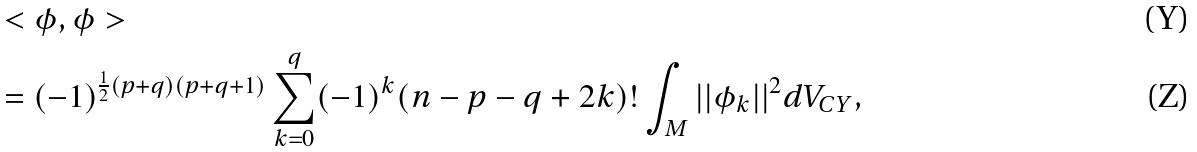Convert formula to latex. <formula><loc_0><loc_0><loc_500><loc_500>& < \phi , \phi > \\ & = ( - 1 ) ^ { \frac { 1 } { 2 } ( p + q ) ( p + q + 1 ) } \sum _ { k = 0 } ^ { q } ( - 1 ) ^ { k } ( n - p - q + 2 k ) ! \int _ { M } | | \phi _ { k } | | ^ { 2 } d V _ { C Y } ,</formula> 